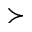<formula> <loc_0><loc_0><loc_500><loc_500>\succ</formula> 